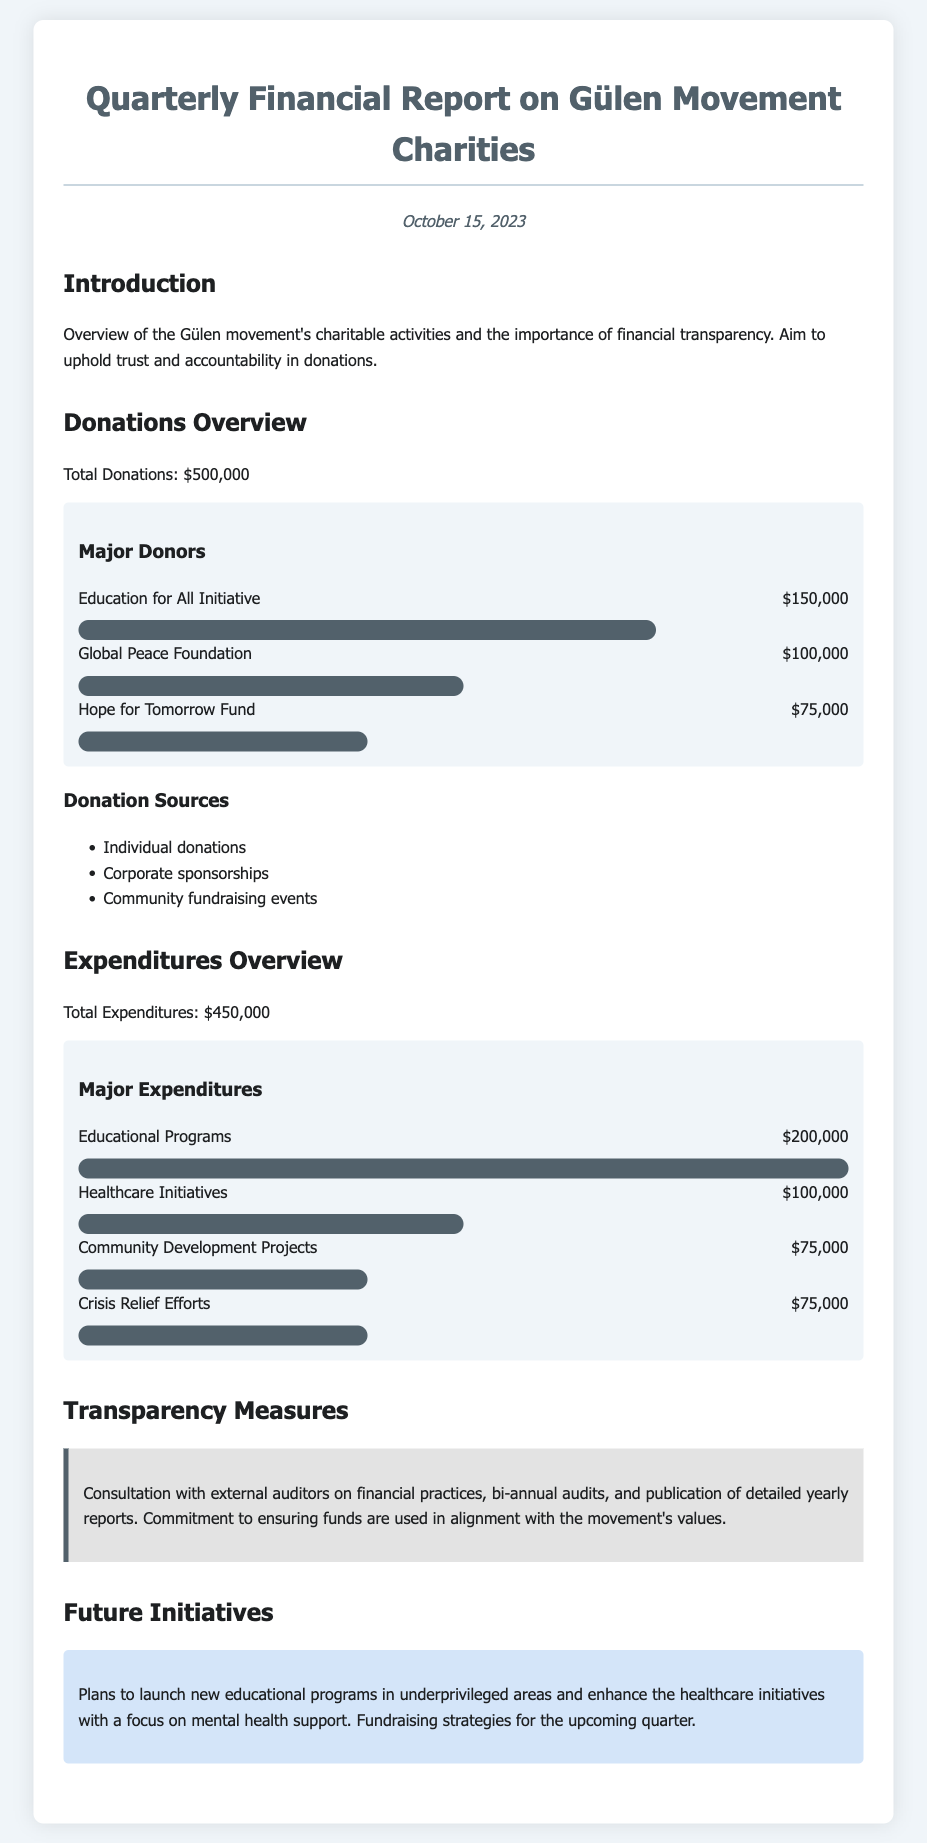What is the total amount of donations? The document states that the total donations amount is provided directly.
Answer: $500,000 What was the expenditure on educational programs? The report explicitly lists the expenditure on educational programs, which is found in the expenditures section.
Answer: $200,000 Who is the major donor providing $150,000? The document lists the donors and their respective contributions, identifying the donor in question.
Answer: Education for All Initiative What percentage of total expenditures is allocated to healthcare initiatives? The healthcare expenditure can be calculated in relation to total expenditures stated in the document.
Answer: 22.2% What are two sources of donations mentioned? The document lists the sources of donations under the Donations Overview section.
Answer: Individual donations, Corporate sponsorships How much was spent on community development projects? The expenditures section directly includes the expenditure for community development projects listed there.
Answer: $75,000 What type of transparency measures are mentioned? The document specifically outlines the transparency measures taken by the organization.
Answer: Consultation with external auditors What major future initiative is planned? The future initiatives indicate the plans for educational programs and healthcare initiatives as outlined.
Answer: New educational programs What is the date of the financial report? The date is mentioned at the top of the document, indicating when the report was published.
Answer: October 15, 2023 